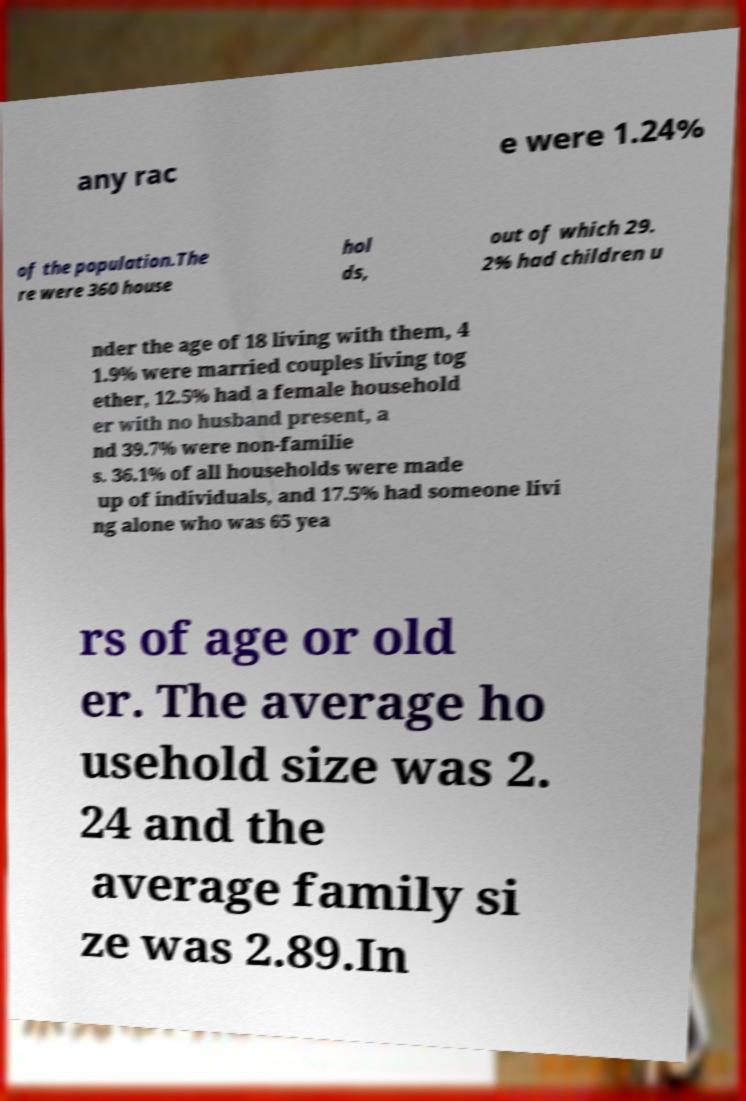I need the written content from this picture converted into text. Can you do that? any rac e were 1.24% of the population.The re were 360 house hol ds, out of which 29. 2% had children u nder the age of 18 living with them, 4 1.9% were married couples living tog ether, 12.5% had a female household er with no husband present, a nd 39.7% were non-familie s. 36.1% of all households were made up of individuals, and 17.5% had someone livi ng alone who was 65 yea rs of age or old er. The average ho usehold size was 2. 24 and the average family si ze was 2.89.In 